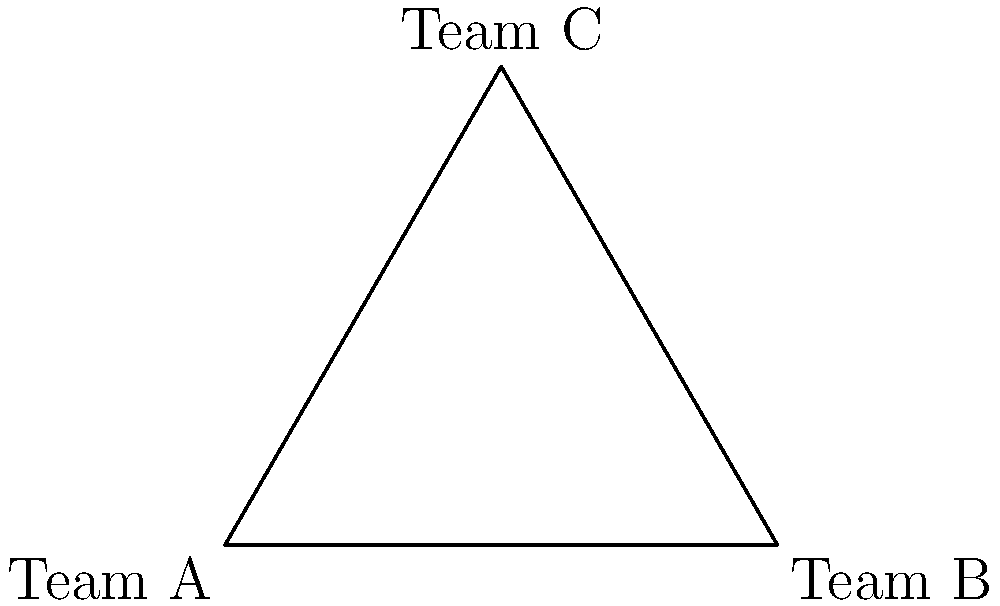In a military unit, three teams (A, B, and C) rotate through different shift schedules in a cyclic manner. If Team A starts on the day shift, Team B on the night shift, and Team C on the evening shift, how many rotations are needed for all teams to have worked each shift exactly once? To solve this problem, we need to understand the concept of cyclic groups in group theory:

1. We have three teams (A, B, C) and three shifts (day, night, evening).
2. Each rotation moves each team to the next shift in the cycle.
3. We need to find the least common multiple (LCM) of the number of teams and the number of shifts.

Step 1: Identify the cycle length
- Number of teams = 3
- Number of shifts = 3

Step 2: Calculate the LCM
LCM(3,3) = 3

Step 3: Interpret the result
The LCM of 3 means that after 3 rotations, all teams will have worked each shift exactly once.

Rotation 1: A (day), B (night), C (evening)
Rotation 2: A (evening), B (day), C (night)
Rotation 3: A (night), B (evening), C (day)

After the 3rd rotation, the cycle completes, and each team has worked each shift once.
Answer: 3 rotations 